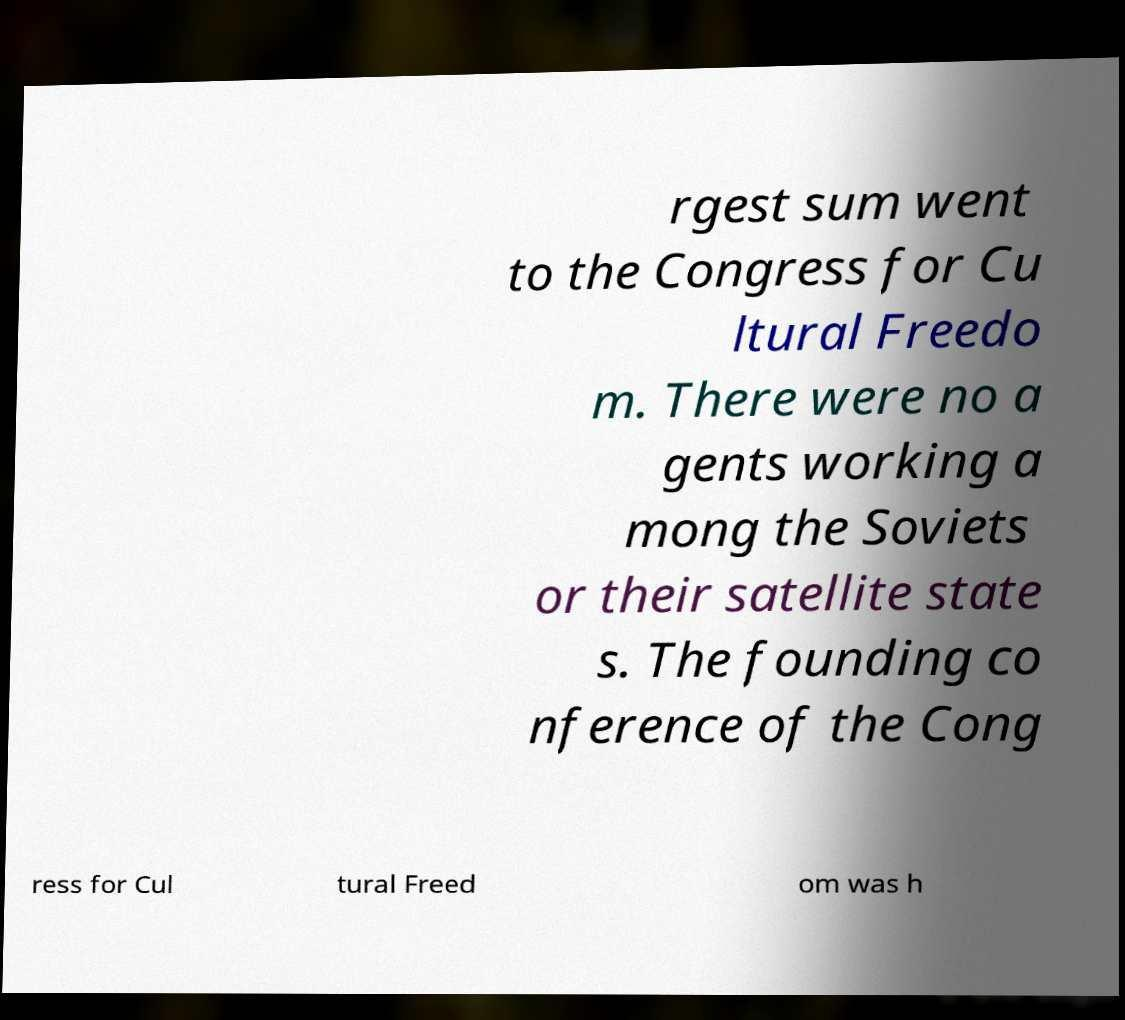I need the written content from this picture converted into text. Can you do that? rgest sum went to the Congress for Cu ltural Freedo m. There were no a gents working a mong the Soviets or their satellite state s. The founding co nference of the Cong ress for Cul tural Freed om was h 